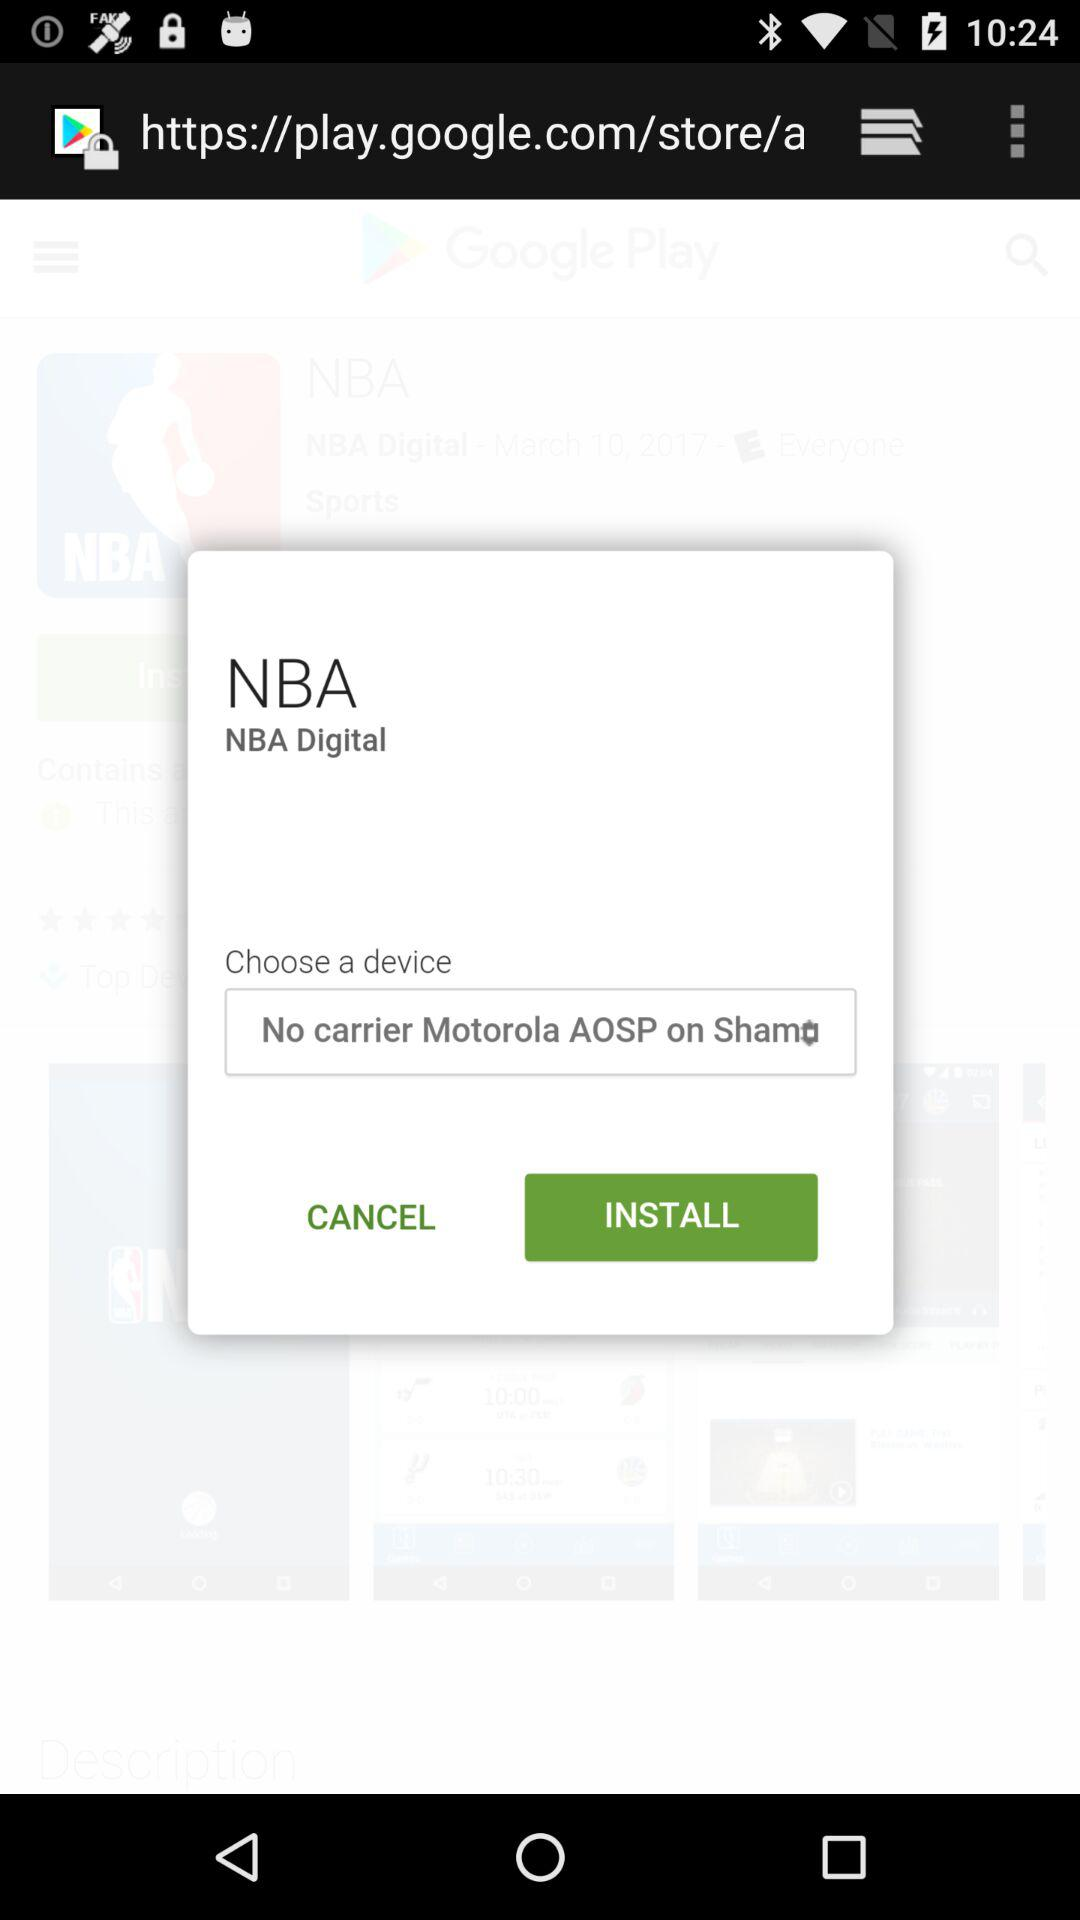What is the application name? The application name is "NBA". 